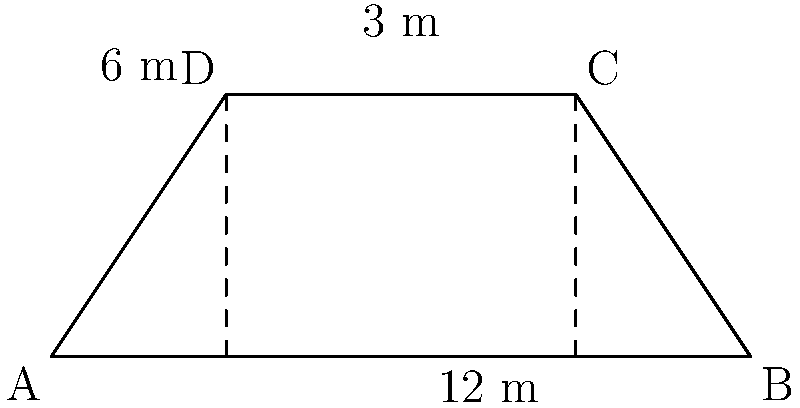A trapezoidal section of a road is shown in the diagram. The parallel sides of the trapezoid measure 6 m and 12 m, and the perpendicular distance between them is 3 m. As a civil engineer, calculate the area of this road section in square meters. To solve this problem, we'll use the formula for the area of a trapezoid:

$$A = \frac{1}{2}(b_1 + b_2)h$$

Where:
$A$ = Area of the trapezoid
$b_1$ and $b_2$ = Lengths of the parallel sides
$h$ = Height (perpendicular distance between parallel sides)

Given:
$b_1 = 6$ m
$b_2 = 12$ m
$h = 3$ m

Let's substitute these values into the formula:

$$A = \frac{1}{2}(6 \text{ m} + 12 \text{ m}) \times 3 \text{ m}$$

$$A = \frac{1}{2}(18 \text{ m}) \times 3 \text{ m}$$

$$A = 9 \text{ m} \times 3 \text{ m}$$

$$A = 27 \text{ m}^2$$

Therefore, the area of the trapezoidal road section is 27 square meters.
Answer: 27 m² 